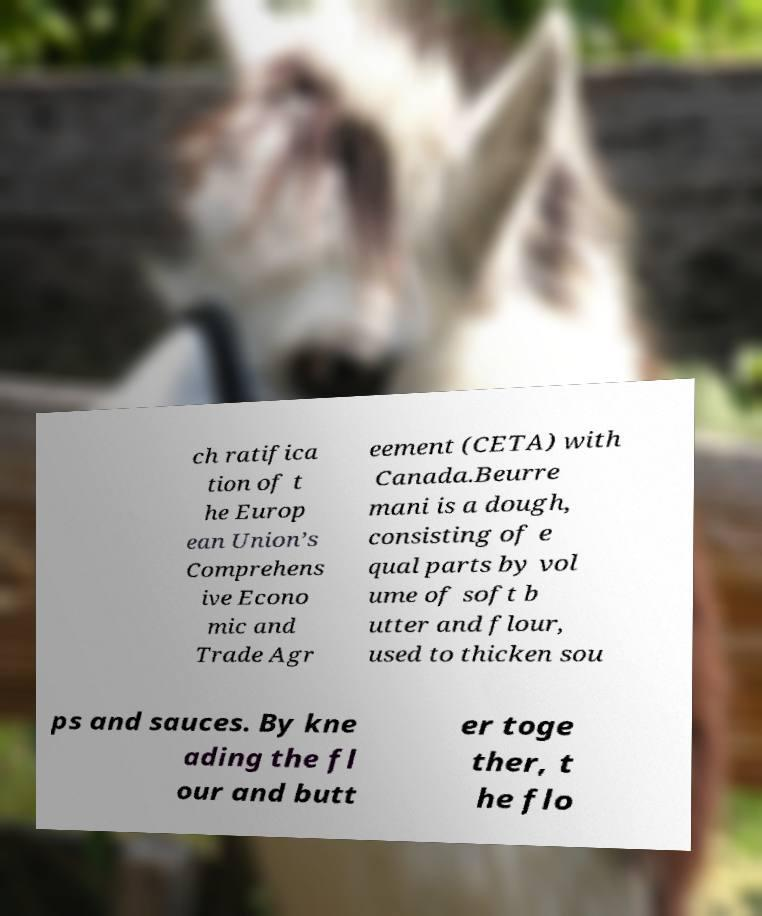Could you extract and type out the text from this image? ch ratifica tion of t he Europ ean Union’s Comprehens ive Econo mic and Trade Agr eement (CETA) with Canada.Beurre mani is a dough, consisting of e qual parts by vol ume of soft b utter and flour, used to thicken sou ps and sauces. By kne ading the fl our and butt er toge ther, t he flo 